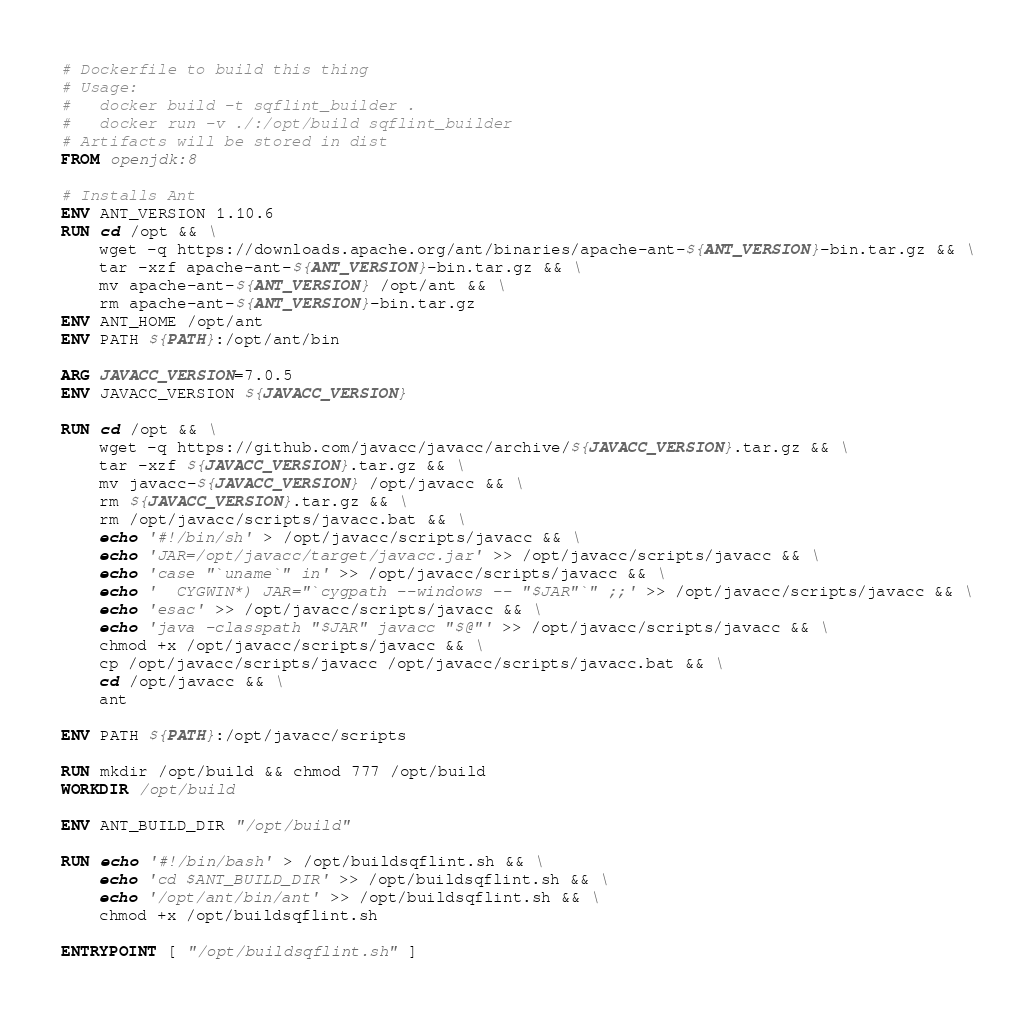<code> <loc_0><loc_0><loc_500><loc_500><_Dockerfile_># Dockerfile to build this thing
# Usage:
#   docker build -t sqflint_builder .
#   docker run -v ./:/opt/build sqflint_builder
# Artifacts will be stored in dist
FROM openjdk:8

# Installs Ant
ENV ANT_VERSION 1.10.6
RUN cd /opt && \
    wget -q https://downloads.apache.org/ant/binaries/apache-ant-${ANT_VERSION}-bin.tar.gz && \
    tar -xzf apache-ant-${ANT_VERSION}-bin.tar.gz && \
    mv apache-ant-${ANT_VERSION} /opt/ant && \
    rm apache-ant-${ANT_VERSION}-bin.tar.gz
ENV ANT_HOME /opt/ant
ENV PATH ${PATH}:/opt/ant/bin

ARG JAVACC_VERSION=7.0.5
ENV JAVACC_VERSION ${JAVACC_VERSION}

RUN cd /opt && \
    wget -q https://github.com/javacc/javacc/archive/${JAVACC_VERSION}.tar.gz && \
    tar -xzf ${JAVACC_VERSION}.tar.gz && \
    mv javacc-${JAVACC_VERSION} /opt/javacc && \
    rm ${JAVACC_VERSION}.tar.gz && \
    rm /opt/javacc/scripts/javacc.bat && \
    echo '#!/bin/sh' > /opt/javacc/scripts/javacc && \
    echo 'JAR=/opt/javacc/target/javacc.jar' >> /opt/javacc/scripts/javacc && \
    echo 'case "`uname`" in' >> /opt/javacc/scripts/javacc && \
    echo '  CYGWIN*) JAR="`cygpath --windows -- "$JAR"`" ;;' >> /opt/javacc/scripts/javacc && \
    echo 'esac' >> /opt/javacc/scripts/javacc && \
    echo 'java -classpath "$JAR" javacc "$@"' >> /opt/javacc/scripts/javacc && \
    chmod +x /opt/javacc/scripts/javacc && \
    cp /opt/javacc/scripts/javacc /opt/javacc/scripts/javacc.bat && \
    cd /opt/javacc && \
    ant

ENV PATH ${PATH}:/opt/javacc/scripts

RUN mkdir /opt/build && chmod 777 /opt/build
WORKDIR /opt/build

ENV ANT_BUILD_DIR "/opt/build"

RUN echo '#!/bin/bash' > /opt/buildsqflint.sh && \
    echo 'cd $ANT_BUILD_DIR' >> /opt/buildsqflint.sh && \
    echo '/opt/ant/bin/ant' >> /opt/buildsqflint.sh && \
    chmod +x /opt/buildsqflint.sh

ENTRYPOINT [ "/opt/buildsqflint.sh" ]


</code> 